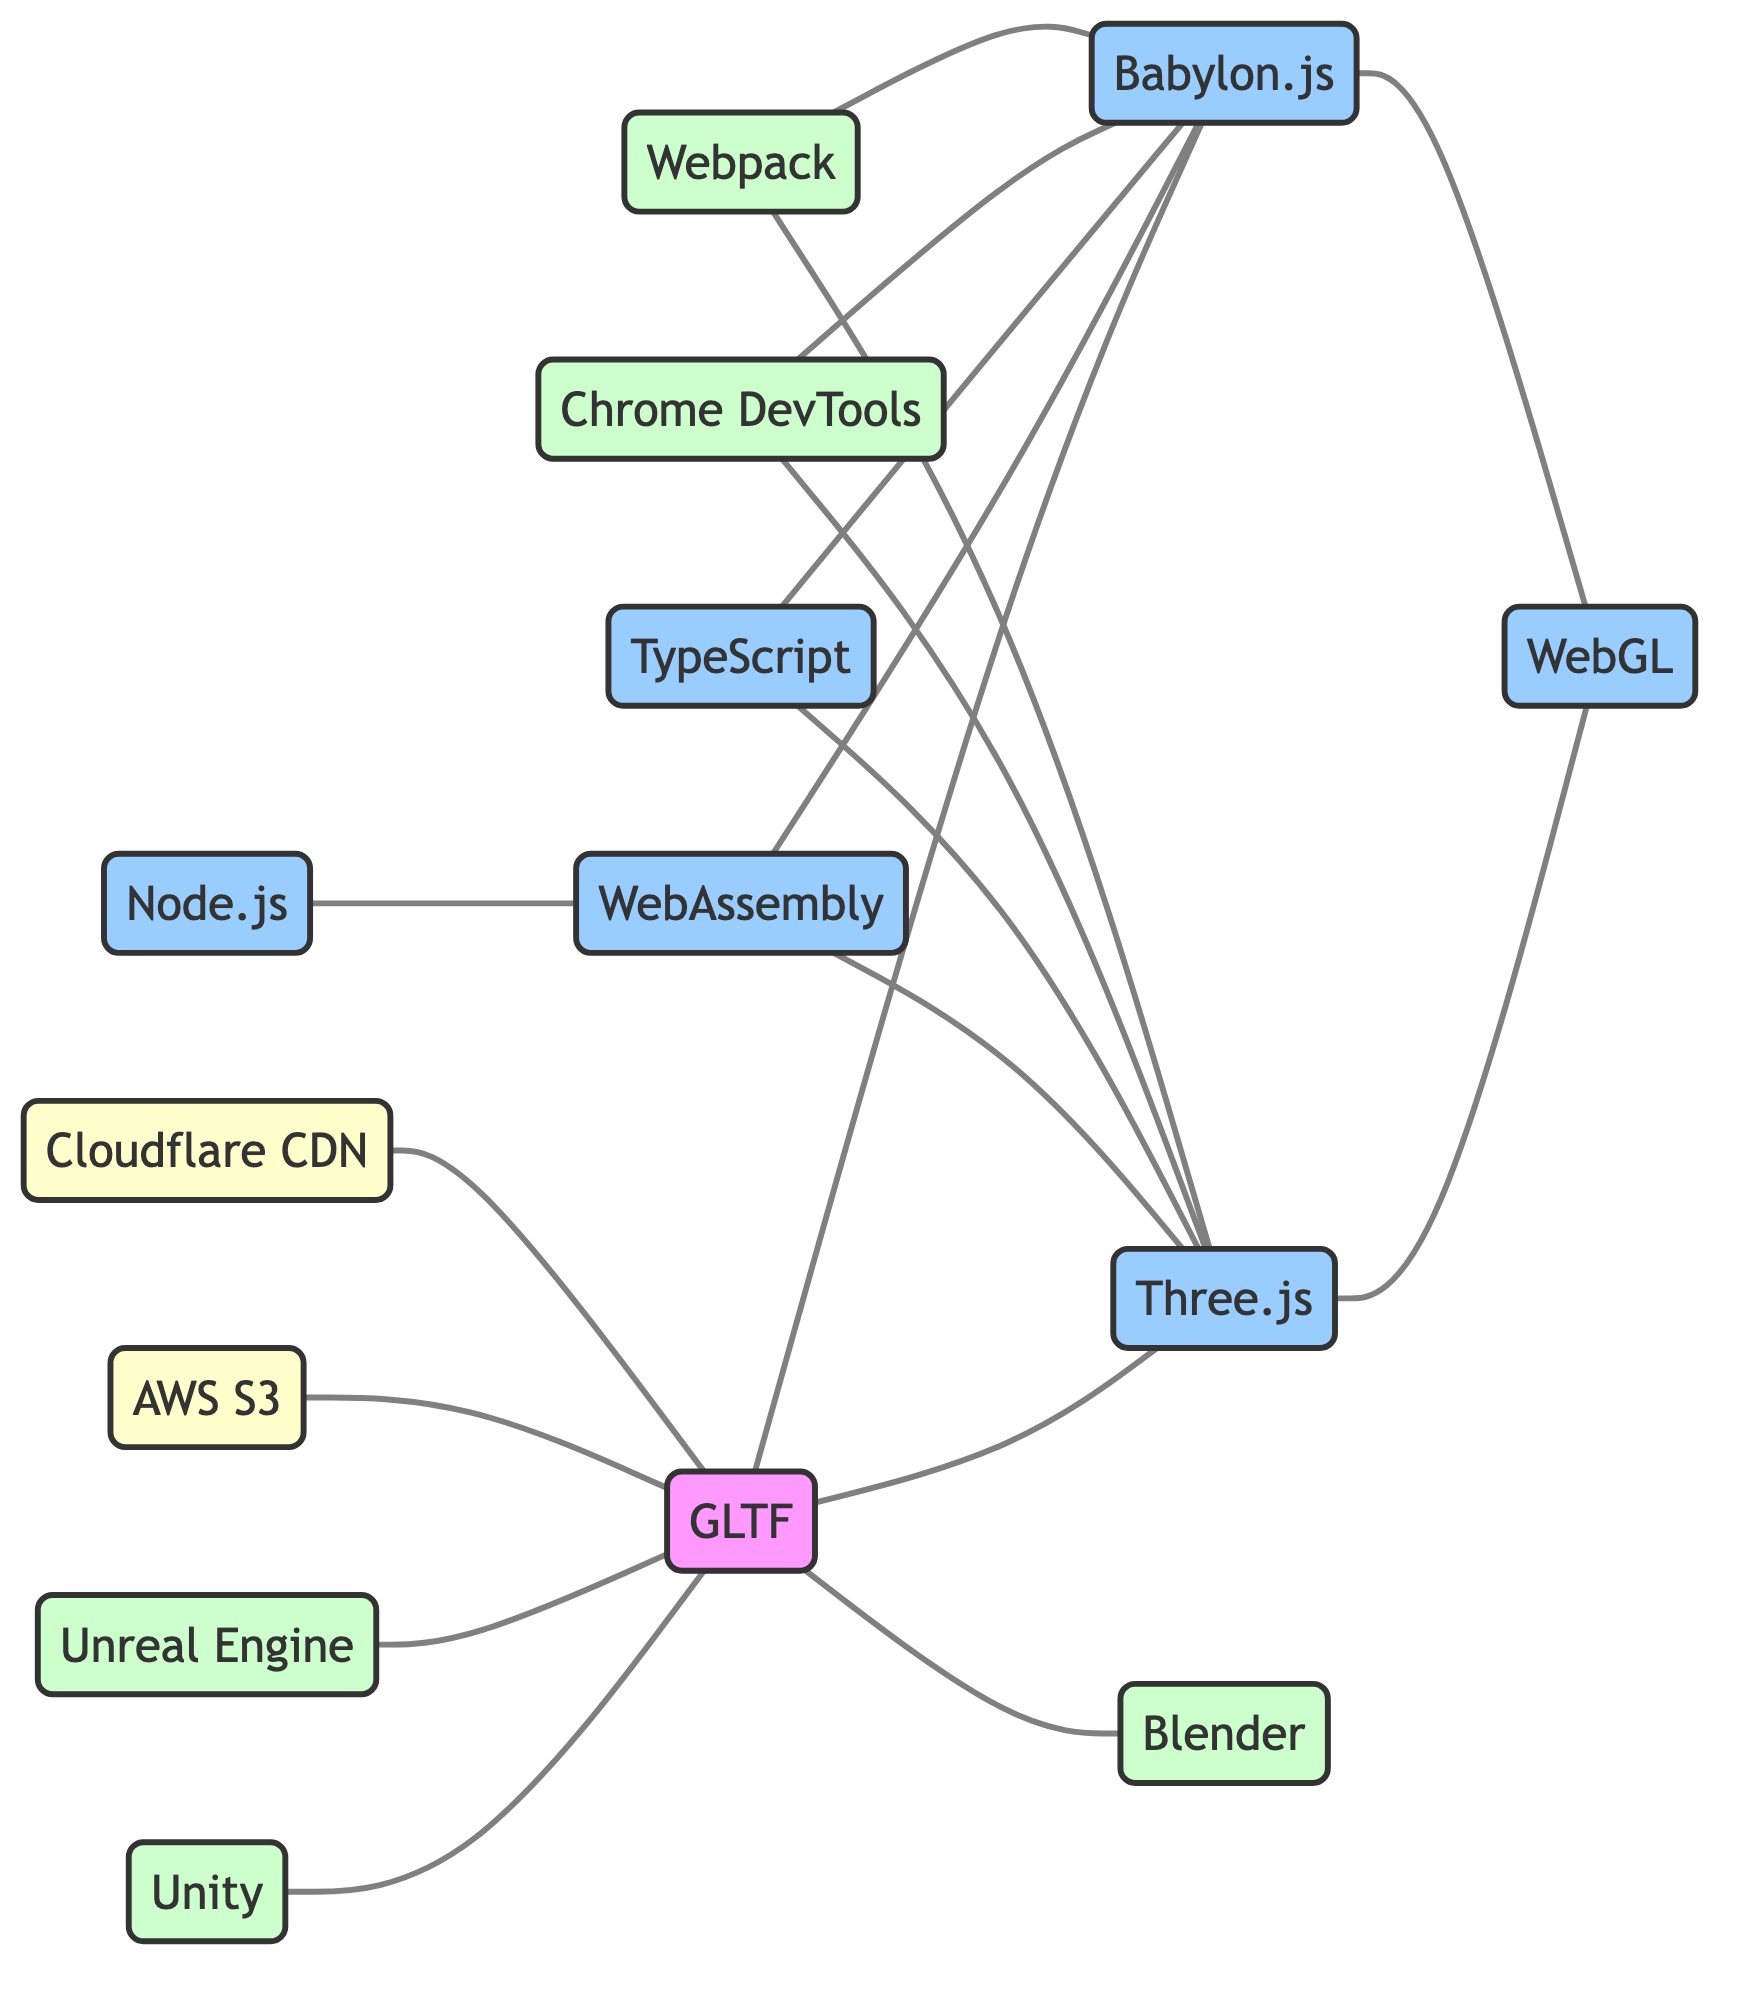What is the total number of nodes in the diagram? The diagram displays a total of 14 unique nodes, which are each representing different tools, technologies, or frameworks related to 3D model performance optimization.
Answer: 14 Which two tools are directly connected to GLTF? The edges indicate that both Blender and Three.js have direct connections to GLTF, implying they are involved in the context related to GLTF.
Answer: Blender, Three.js How many technologies have a connection to WebGL? In the diagram, Three.js and Babylon.js each connect to WebGL, thus showing they both utilize this web technology for rendering 3D graphics.
Answer: 2 Which tool connects to both Three.js and Babylon.js via a common technology? The diagram shows that both WebAssembly and TypeScript have connections to Three.js and Babylon.js, establishing them as common technologies utilized in both contexts.
Answer: WebAssembly, TypeScript Which node has the most connections in the graph? By analyzing the edges, GLTF is connected with multiple nodes: Blender, Three.js, Babylon.js, Unity, and Unreal Engine, making it the node with the highest number of connections.
Answer: GLTF 